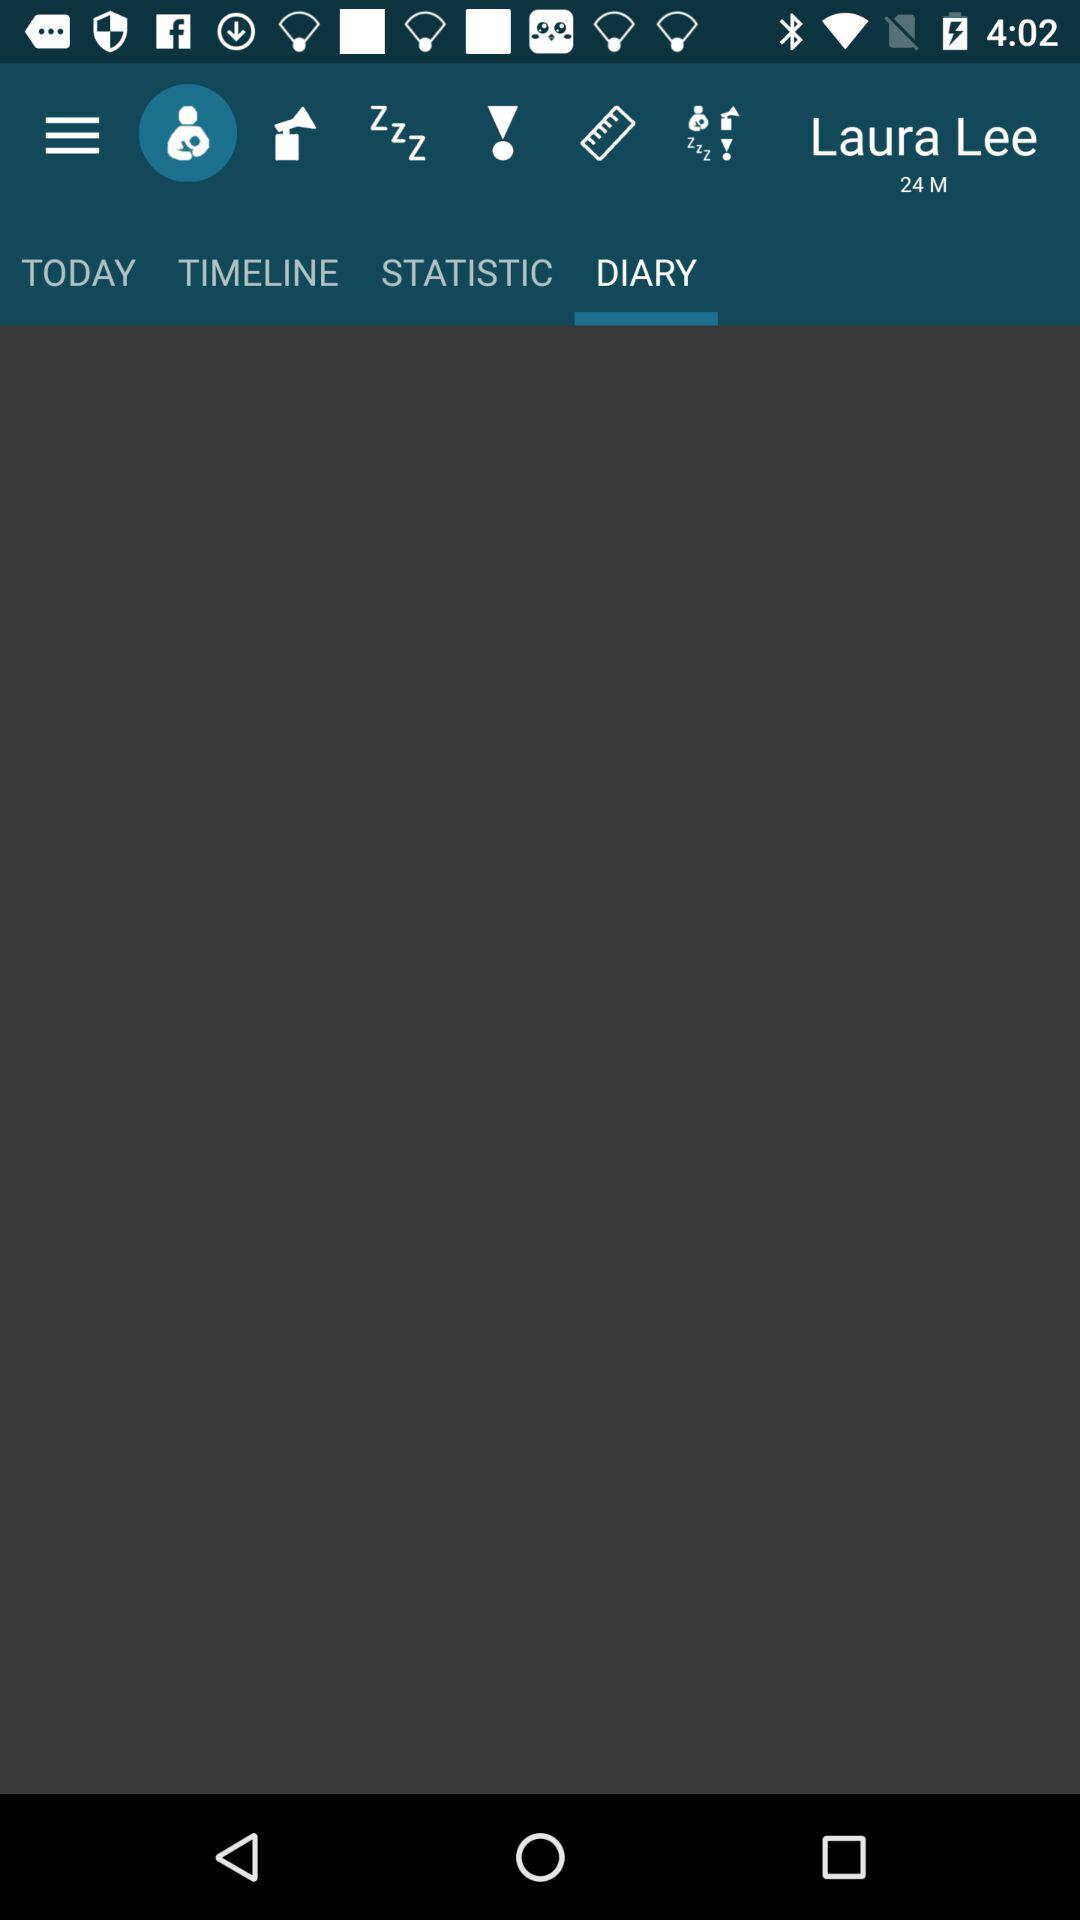Which option is selected in the menu bar? The selected option is "Diary". 